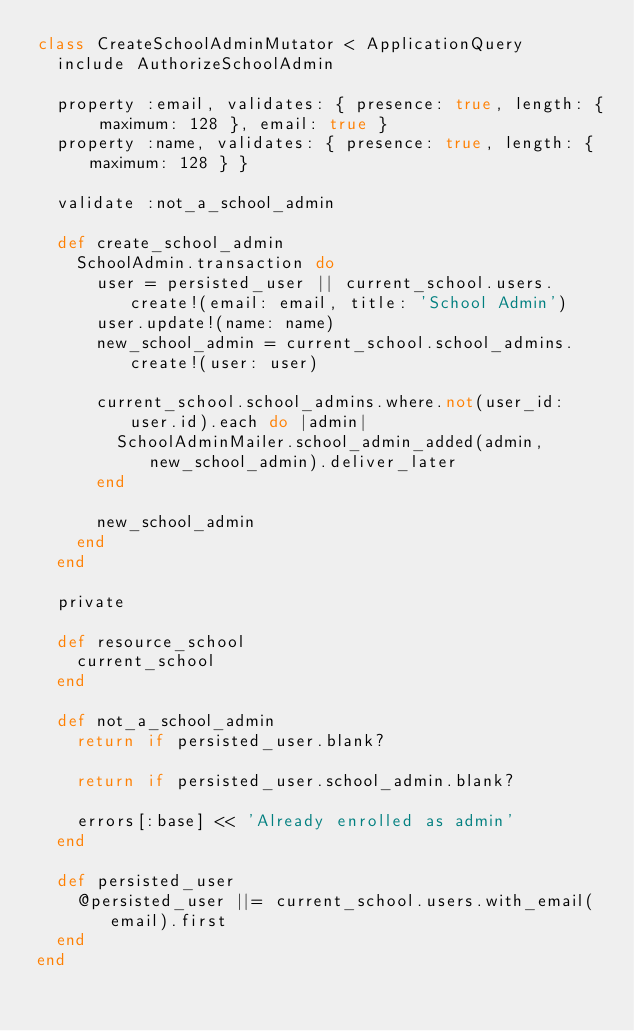Convert code to text. <code><loc_0><loc_0><loc_500><loc_500><_Ruby_>class CreateSchoolAdminMutator < ApplicationQuery
  include AuthorizeSchoolAdmin

  property :email, validates: { presence: true, length: { maximum: 128 }, email: true }
  property :name, validates: { presence: true, length: { maximum: 128 } }

  validate :not_a_school_admin

  def create_school_admin
    SchoolAdmin.transaction do
      user = persisted_user || current_school.users.create!(email: email, title: 'School Admin')
      user.update!(name: name)
      new_school_admin = current_school.school_admins.create!(user: user)

      current_school.school_admins.where.not(user_id: user.id).each do |admin|
        SchoolAdminMailer.school_admin_added(admin, new_school_admin).deliver_later
      end

      new_school_admin
    end
  end

  private

  def resource_school
    current_school
  end

  def not_a_school_admin
    return if persisted_user.blank?

    return if persisted_user.school_admin.blank?

    errors[:base] << 'Already enrolled as admin'
  end

  def persisted_user
    @persisted_user ||= current_school.users.with_email(email).first
  end
end
</code> 